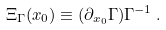Convert formula to latex. <formula><loc_0><loc_0><loc_500><loc_500>\Xi _ { \Gamma } ( x _ { 0 } ) \equiv ( \partial _ { x _ { 0 } } \Gamma ) \Gamma ^ { - 1 } \, .</formula> 